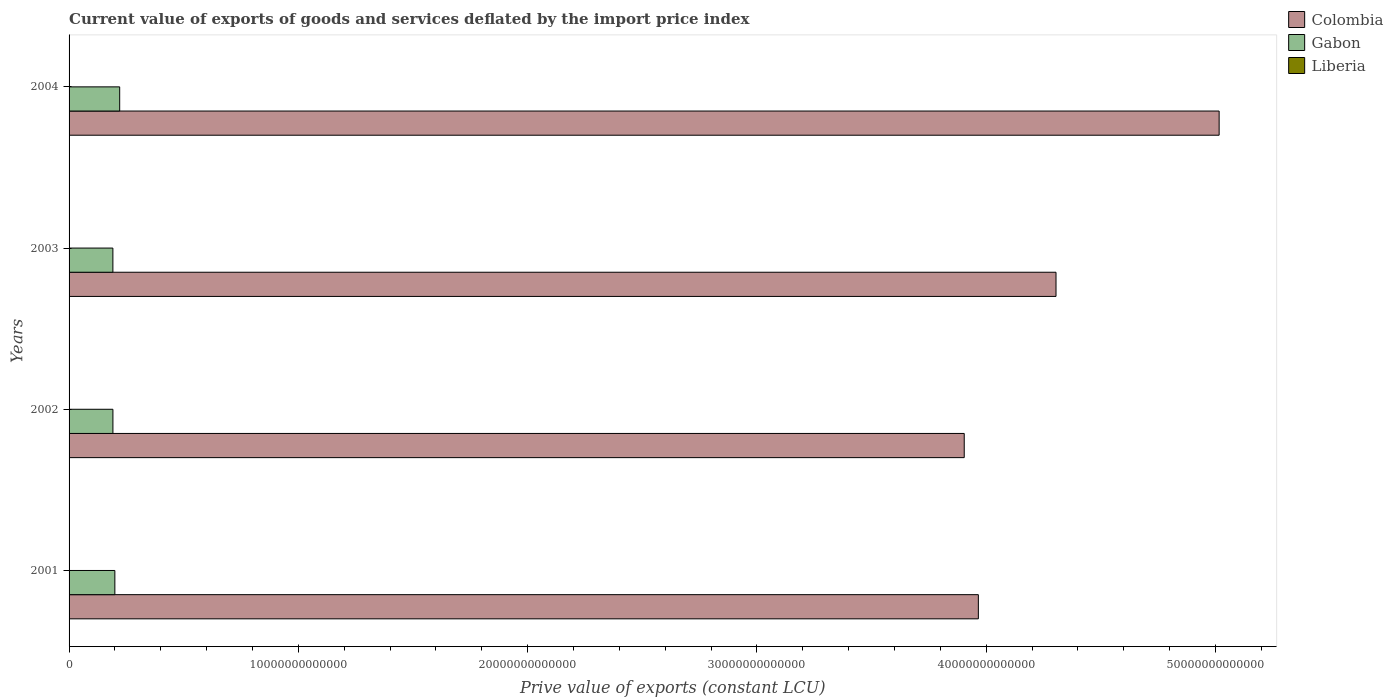How many different coloured bars are there?
Provide a short and direct response. 3. How many groups of bars are there?
Offer a very short reply. 4. Are the number of bars per tick equal to the number of legend labels?
Ensure brevity in your answer.  Yes. How many bars are there on the 4th tick from the top?
Provide a short and direct response. 3. How many bars are there on the 2nd tick from the bottom?
Your answer should be compact. 3. In how many cases, is the number of bars for a given year not equal to the number of legend labels?
Offer a very short reply. 0. What is the prive value of exports in Gabon in 2004?
Your answer should be compact. 2.21e+12. Across all years, what is the maximum prive value of exports in Gabon?
Provide a short and direct response. 2.21e+12. Across all years, what is the minimum prive value of exports in Liberia?
Offer a very short reply. 4.52e+07. In which year was the prive value of exports in Gabon maximum?
Offer a terse response. 2004. In which year was the prive value of exports in Liberia minimum?
Your answer should be very brief. 2004. What is the total prive value of exports in Liberia in the graph?
Provide a short and direct response. 6.12e+08. What is the difference between the prive value of exports in Colombia in 2003 and that in 2004?
Your answer should be compact. -7.11e+12. What is the difference between the prive value of exports in Colombia in 2004 and the prive value of exports in Gabon in 2003?
Offer a terse response. 4.82e+13. What is the average prive value of exports in Liberia per year?
Your answer should be compact. 1.53e+08. In the year 2002, what is the difference between the prive value of exports in Gabon and prive value of exports in Colombia?
Your answer should be very brief. -3.71e+13. In how many years, is the prive value of exports in Gabon greater than 2000000000000 LCU?
Offer a very short reply. 1. What is the ratio of the prive value of exports in Colombia in 2001 to that in 2002?
Provide a short and direct response. 1.02. What is the difference between the highest and the second highest prive value of exports in Gabon?
Your response must be concise. 2.11e+11. What is the difference between the highest and the lowest prive value of exports in Colombia?
Your answer should be compact. 1.11e+13. What does the 1st bar from the top in 2001 represents?
Your response must be concise. Liberia. What does the 1st bar from the bottom in 2001 represents?
Your response must be concise. Colombia. Is it the case that in every year, the sum of the prive value of exports in Colombia and prive value of exports in Liberia is greater than the prive value of exports in Gabon?
Provide a succinct answer. Yes. What is the difference between two consecutive major ticks on the X-axis?
Provide a short and direct response. 1.00e+13. Does the graph contain grids?
Provide a succinct answer. No. What is the title of the graph?
Make the answer very short. Current value of exports of goods and services deflated by the import price index. Does "United Arab Emirates" appear as one of the legend labels in the graph?
Provide a succinct answer. No. What is the label or title of the X-axis?
Offer a terse response. Prive value of exports (constant LCU). What is the Prive value of exports (constant LCU) in Colombia in 2001?
Keep it short and to the point. 3.97e+13. What is the Prive value of exports (constant LCU) in Gabon in 2001?
Your answer should be compact. 2.00e+12. What is the Prive value of exports (constant LCU) of Liberia in 2001?
Ensure brevity in your answer.  1.85e+08. What is the Prive value of exports (constant LCU) of Colombia in 2002?
Your answer should be very brief. 3.90e+13. What is the Prive value of exports (constant LCU) in Gabon in 2002?
Your response must be concise. 1.91e+12. What is the Prive value of exports (constant LCU) of Liberia in 2002?
Offer a terse response. 2.39e+08. What is the Prive value of exports (constant LCU) of Colombia in 2003?
Your response must be concise. 4.30e+13. What is the Prive value of exports (constant LCU) in Gabon in 2003?
Provide a succinct answer. 1.91e+12. What is the Prive value of exports (constant LCU) in Liberia in 2003?
Your response must be concise. 1.42e+08. What is the Prive value of exports (constant LCU) of Colombia in 2004?
Offer a terse response. 5.02e+13. What is the Prive value of exports (constant LCU) of Gabon in 2004?
Your answer should be very brief. 2.21e+12. What is the Prive value of exports (constant LCU) in Liberia in 2004?
Offer a terse response. 4.52e+07. Across all years, what is the maximum Prive value of exports (constant LCU) in Colombia?
Your answer should be very brief. 5.02e+13. Across all years, what is the maximum Prive value of exports (constant LCU) in Gabon?
Ensure brevity in your answer.  2.21e+12. Across all years, what is the maximum Prive value of exports (constant LCU) of Liberia?
Make the answer very short. 2.39e+08. Across all years, what is the minimum Prive value of exports (constant LCU) of Colombia?
Give a very brief answer. 3.90e+13. Across all years, what is the minimum Prive value of exports (constant LCU) in Gabon?
Provide a short and direct response. 1.91e+12. Across all years, what is the minimum Prive value of exports (constant LCU) in Liberia?
Keep it short and to the point. 4.52e+07. What is the total Prive value of exports (constant LCU) in Colombia in the graph?
Offer a very short reply. 1.72e+14. What is the total Prive value of exports (constant LCU) in Gabon in the graph?
Ensure brevity in your answer.  8.03e+12. What is the total Prive value of exports (constant LCU) in Liberia in the graph?
Provide a short and direct response. 6.12e+08. What is the difference between the Prive value of exports (constant LCU) in Colombia in 2001 and that in 2002?
Provide a succinct answer. 6.16e+11. What is the difference between the Prive value of exports (constant LCU) of Gabon in 2001 and that in 2002?
Provide a short and direct response. 8.46e+1. What is the difference between the Prive value of exports (constant LCU) in Liberia in 2001 and that in 2002?
Give a very brief answer. -5.44e+07. What is the difference between the Prive value of exports (constant LCU) in Colombia in 2001 and that in 2003?
Offer a terse response. -3.39e+12. What is the difference between the Prive value of exports (constant LCU) of Gabon in 2001 and that in 2003?
Your answer should be compact. 8.59e+1. What is the difference between the Prive value of exports (constant LCU) of Liberia in 2001 and that in 2003?
Offer a terse response. 4.26e+07. What is the difference between the Prive value of exports (constant LCU) of Colombia in 2001 and that in 2004?
Your response must be concise. -1.05e+13. What is the difference between the Prive value of exports (constant LCU) of Gabon in 2001 and that in 2004?
Your answer should be compact. -2.11e+11. What is the difference between the Prive value of exports (constant LCU) of Liberia in 2001 and that in 2004?
Your answer should be very brief. 1.40e+08. What is the difference between the Prive value of exports (constant LCU) of Colombia in 2002 and that in 2003?
Offer a terse response. -4.00e+12. What is the difference between the Prive value of exports (constant LCU) of Gabon in 2002 and that in 2003?
Offer a terse response. 1.37e+09. What is the difference between the Prive value of exports (constant LCU) of Liberia in 2002 and that in 2003?
Your answer should be very brief. 9.70e+07. What is the difference between the Prive value of exports (constant LCU) in Colombia in 2002 and that in 2004?
Your response must be concise. -1.11e+13. What is the difference between the Prive value of exports (constant LCU) of Gabon in 2002 and that in 2004?
Offer a very short reply. -2.95e+11. What is the difference between the Prive value of exports (constant LCU) of Liberia in 2002 and that in 2004?
Provide a succinct answer. 1.94e+08. What is the difference between the Prive value of exports (constant LCU) in Colombia in 2003 and that in 2004?
Offer a very short reply. -7.11e+12. What is the difference between the Prive value of exports (constant LCU) in Gabon in 2003 and that in 2004?
Provide a short and direct response. -2.97e+11. What is the difference between the Prive value of exports (constant LCU) in Liberia in 2003 and that in 2004?
Ensure brevity in your answer.  9.71e+07. What is the difference between the Prive value of exports (constant LCU) of Colombia in 2001 and the Prive value of exports (constant LCU) of Gabon in 2002?
Provide a short and direct response. 3.77e+13. What is the difference between the Prive value of exports (constant LCU) in Colombia in 2001 and the Prive value of exports (constant LCU) in Liberia in 2002?
Your answer should be very brief. 3.97e+13. What is the difference between the Prive value of exports (constant LCU) of Gabon in 2001 and the Prive value of exports (constant LCU) of Liberia in 2002?
Offer a terse response. 2.00e+12. What is the difference between the Prive value of exports (constant LCU) of Colombia in 2001 and the Prive value of exports (constant LCU) of Gabon in 2003?
Offer a terse response. 3.77e+13. What is the difference between the Prive value of exports (constant LCU) in Colombia in 2001 and the Prive value of exports (constant LCU) in Liberia in 2003?
Your answer should be compact. 3.97e+13. What is the difference between the Prive value of exports (constant LCU) in Gabon in 2001 and the Prive value of exports (constant LCU) in Liberia in 2003?
Offer a terse response. 2.00e+12. What is the difference between the Prive value of exports (constant LCU) of Colombia in 2001 and the Prive value of exports (constant LCU) of Gabon in 2004?
Give a very brief answer. 3.74e+13. What is the difference between the Prive value of exports (constant LCU) of Colombia in 2001 and the Prive value of exports (constant LCU) of Liberia in 2004?
Offer a terse response. 3.97e+13. What is the difference between the Prive value of exports (constant LCU) of Gabon in 2001 and the Prive value of exports (constant LCU) of Liberia in 2004?
Provide a short and direct response. 2.00e+12. What is the difference between the Prive value of exports (constant LCU) in Colombia in 2002 and the Prive value of exports (constant LCU) in Gabon in 2003?
Your answer should be very brief. 3.71e+13. What is the difference between the Prive value of exports (constant LCU) in Colombia in 2002 and the Prive value of exports (constant LCU) in Liberia in 2003?
Your response must be concise. 3.90e+13. What is the difference between the Prive value of exports (constant LCU) of Gabon in 2002 and the Prive value of exports (constant LCU) of Liberia in 2003?
Give a very brief answer. 1.91e+12. What is the difference between the Prive value of exports (constant LCU) of Colombia in 2002 and the Prive value of exports (constant LCU) of Gabon in 2004?
Keep it short and to the point. 3.68e+13. What is the difference between the Prive value of exports (constant LCU) in Colombia in 2002 and the Prive value of exports (constant LCU) in Liberia in 2004?
Offer a terse response. 3.90e+13. What is the difference between the Prive value of exports (constant LCU) in Gabon in 2002 and the Prive value of exports (constant LCU) in Liberia in 2004?
Offer a very short reply. 1.91e+12. What is the difference between the Prive value of exports (constant LCU) of Colombia in 2003 and the Prive value of exports (constant LCU) of Gabon in 2004?
Your answer should be compact. 4.08e+13. What is the difference between the Prive value of exports (constant LCU) in Colombia in 2003 and the Prive value of exports (constant LCU) in Liberia in 2004?
Keep it short and to the point. 4.30e+13. What is the difference between the Prive value of exports (constant LCU) of Gabon in 2003 and the Prive value of exports (constant LCU) of Liberia in 2004?
Your response must be concise. 1.91e+12. What is the average Prive value of exports (constant LCU) in Colombia per year?
Offer a terse response. 4.30e+13. What is the average Prive value of exports (constant LCU) in Gabon per year?
Make the answer very short. 2.01e+12. What is the average Prive value of exports (constant LCU) in Liberia per year?
Keep it short and to the point. 1.53e+08. In the year 2001, what is the difference between the Prive value of exports (constant LCU) of Colombia and Prive value of exports (constant LCU) of Gabon?
Your answer should be very brief. 3.77e+13. In the year 2001, what is the difference between the Prive value of exports (constant LCU) of Colombia and Prive value of exports (constant LCU) of Liberia?
Offer a very short reply. 3.97e+13. In the year 2001, what is the difference between the Prive value of exports (constant LCU) in Gabon and Prive value of exports (constant LCU) in Liberia?
Your answer should be very brief. 2.00e+12. In the year 2002, what is the difference between the Prive value of exports (constant LCU) of Colombia and Prive value of exports (constant LCU) of Gabon?
Offer a terse response. 3.71e+13. In the year 2002, what is the difference between the Prive value of exports (constant LCU) of Colombia and Prive value of exports (constant LCU) of Liberia?
Ensure brevity in your answer.  3.90e+13. In the year 2002, what is the difference between the Prive value of exports (constant LCU) in Gabon and Prive value of exports (constant LCU) in Liberia?
Offer a terse response. 1.91e+12. In the year 2003, what is the difference between the Prive value of exports (constant LCU) in Colombia and Prive value of exports (constant LCU) in Gabon?
Your answer should be compact. 4.11e+13. In the year 2003, what is the difference between the Prive value of exports (constant LCU) of Colombia and Prive value of exports (constant LCU) of Liberia?
Provide a short and direct response. 4.30e+13. In the year 2003, what is the difference between the Prive value of exports (constant LCU) in Gabon and Prive value of exports (constant LCU) in Liberia?
Ensure brevity in your answer.  1.91e+12. In the year 2004, what is the difference between the Prive value of exports (constant LCU) of Colombia and Prive value of exports (constant LCU) of Gabon?
Provide a short and direct response. 4.79e+13. In the year 2004, what is the difference between the Prive value of exports (constant LCU) of Colombia and Prive value of exports (constant LCU) of Liberia?
Provide a short and direct response. 5.02e+13. In the year 2004, what is the difference between the Prive value of exports (constant LCU) of Gabon and Prive value of exports (constant LCU) of Liberia?
Your response must be concise. 2.21e+12. What is the ratio of the Prive value of exports (constant LCU) of Colombia in 2001 to that in 2002?
Offer a very short reply. 1.02. What is the ratio of the Prive value of exports (constant LCU) in Gabon in 2001 to that in 2002?
Offer a terse response. 1.04. What is the ratio of the Prive value of exports (constant LCU) in Liberia in 2001 to that in 2002?
Your response must be concise. 0.77. What is the ratio of the Prive value of exports (constant LCU) in Colombia in 2001 to that in 2003?
Give a very brief answer. 0.92. What is the ratio of the Prive value of exports (constant LCU) of Gabon in 2001 to that in 2003?
Provide a succinct answer. 1.04. What is the ratio of the Prive value of exports (constant LCU) in Liberia in 2001 to that in 2003?
Your response must be concise. 1.3. What is the ratio of the Prive value of exports (constant LCU) of Colombia in 2001 to that in 2004?
Offer a very short reply. 0.79. What is the ratio of the Prive value of exports (constant LCU) of Gabon in 2001 to that in 2004?
Provide a short and direct response. 0.9. What is the ratio of the Prive value of exports (constant LCU) in Liberia in 2001 to that in 2004?
Keep it short and to the point. 4.09. What is the ratio of the Prive value of exports (constant LCU) in Colombia in 2002 to that in 2003?
Provide a short and direct response. 0.91. What is the ratio of the Prive value of exports (constant LCU) in Liberia in 2002 to that in 2003?
Make the answer very short. 1.68. What is the ratio of the Prive value of exports (constant LCU) in Colombia in 2002 to that in 2004?
Your response must be concise. 0.78. What is the ratio of the Prive value of exports (constant LCU) of Gabon in 2002 to that in 2004?
Offer a terse response. 0.87. What is the ratio of the Prive value of exports (constant LCU) of Liberia in 2002 to that in 2004?
Your answer should be compact. 5.3. What is the ratio of the Prive value of exports (constant LCU) of Colombia in 2003 to that in 2004?
Make the answer very short. 0.86. What is the ratio of the Prive value of exports (constant LCU) of Gabon in 2003 to that in 2004?
Provide a short and direct response. 0.87. What is the ratio of the Prive value of exports (constant LCU) of Liberia in 2003 to that in 2004?
Your answer should be compact. 3.15. What is the difference between the highest and the second highest Prive value of exports (constant LCU) in Colombia?
Offer a terse response. 7.11e+12. What is the difference between the highest and the second highest Prive value of exports (constant LCU) in Gabon?
Your answer should be compact. 2.11e+11. What is the difference between the highest and the second highest Prive value of exports (constant LCU) in Liberia?
Your answer should be very brief. 5.44e+07. What is the difference between the highest and the lowest Prive value of exports (constant LCU) in Colombia?
Provide a short and direct response. 1.11e+13. What is the difference between the highest and the lowest Prive value of exports (constant LCU) in Gabon?
Offer a very short reply. 2.97e+11. What is the difference between the highest and the lowest Prive value of exports (constant LCU) in Liberia?
Offer a terse response. 1.94e+08. 